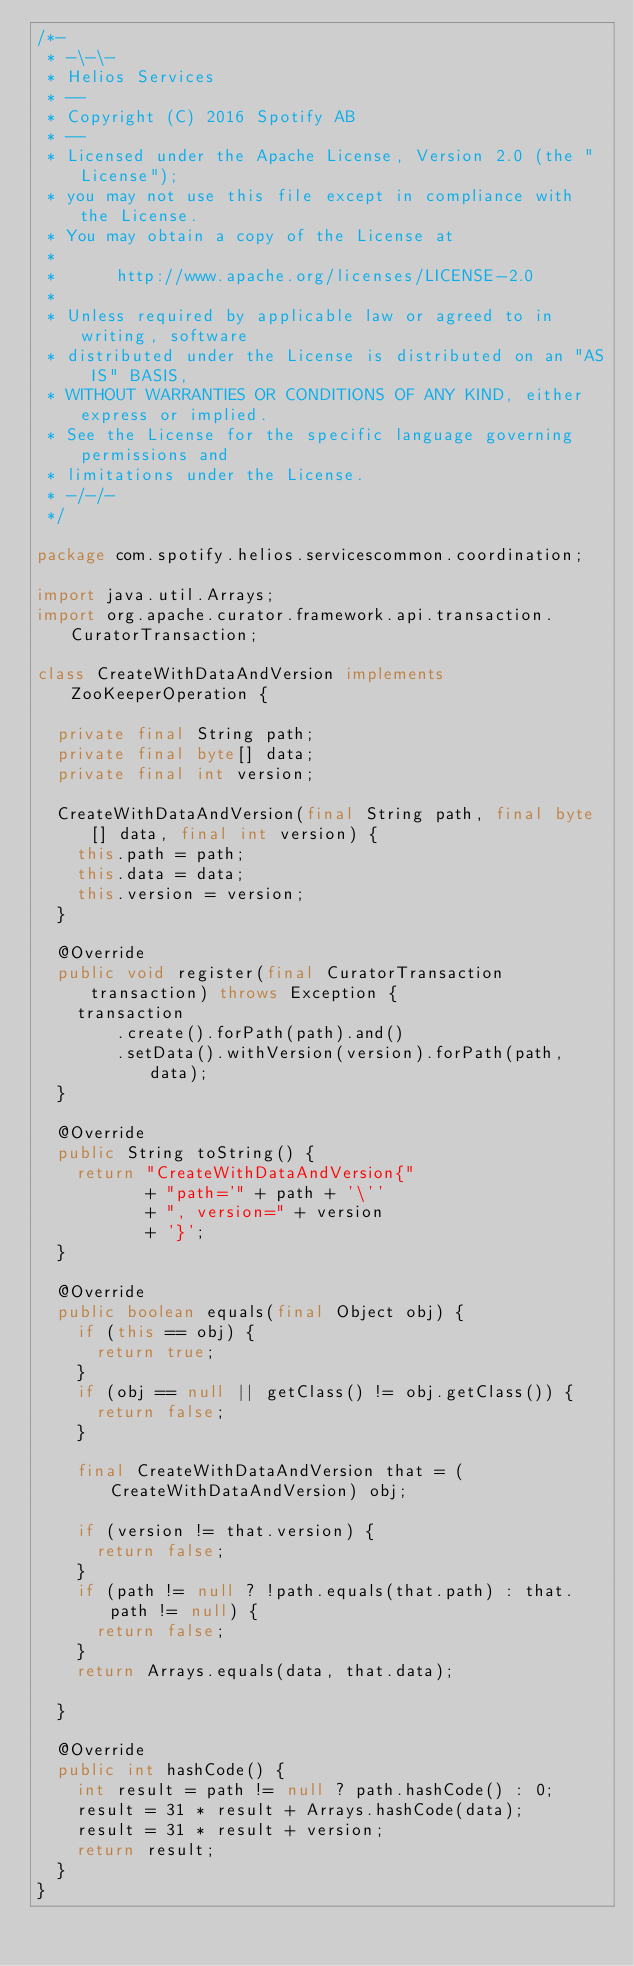<code> <loc_0><loc_0><loc_500><loc_500><_Java_>/*-
 * -\-\-
 * Helios Services
 * --
 * Copyright (C) 2016 Spotify AB
 * --
 * Licensed under the Apache License, Version 2.0 (the "License");
 * you may not use this file except in compliance with the License.
 * You may obtain a copy of the License at
 * 
 *      http://www.apache.org/licenses/LICENSE-2.0
 * 
 * Unless required by applicable law or agreed to in writing, software
 * distributed under the License is distributed on an "AS IS" BASIS,
 * WITHOUT WARRANTIES OR CONDITIONS OF ANY KIND, either express or implied.
 * See the License for the specific language governing permissions and
 * limitations under the License.
 * -/-/-
 */

package com.spotify.helios.servicescommon.coordination;

import java.util.Arrays;
import org.apache.curator.framework.api.transaction.CuratorTransaction;

class CreateWithDataAndVersion implements ZooKeeperOperation {

  private final String path;
  private final byte[] data;
  private final int version;

  CreateWithDataAndVersion(final String path, final byte[] data, final int version) {
    this.path = path;
    this.data = data;
    this.version = version;
  }

  @Override
  public void register(final CuratorTransaction transaction) throws Exception {
    transaction
        .create().forPath(path).and()
        .setData().withVersion(version).forPath(path, data);
  }

  @Override
  public String toString() {
    return "CreateWithDataAndVersion{"
           + "path='" + path + '\''
           + ", version=" + version
           + '}';
  }

  @Override
  public boolean equals(final Object obj) {
    if (this == obj) {
      return true;
    }
    if (obj == null || getClass() != obj.getClass()) {
      return false;
    }

    final CreateWithDataAndVersion that = (CreateWithDataAndVersion) obj;

    if (version != that.version) {
      return false;
    }
    if (path != null ? !path.equals(that.path) : that.path != null) {
      return false;
    }
    return Arrays.equals(data, that.data);

  }

  @Override
  public int hashCode() {
    int result = path != null ? path.hashCode() : 0;
    result = 31 * result + Arrays.hashCode(data);
    result = 31 * result + version;
    return result;
  }
}
</code> 